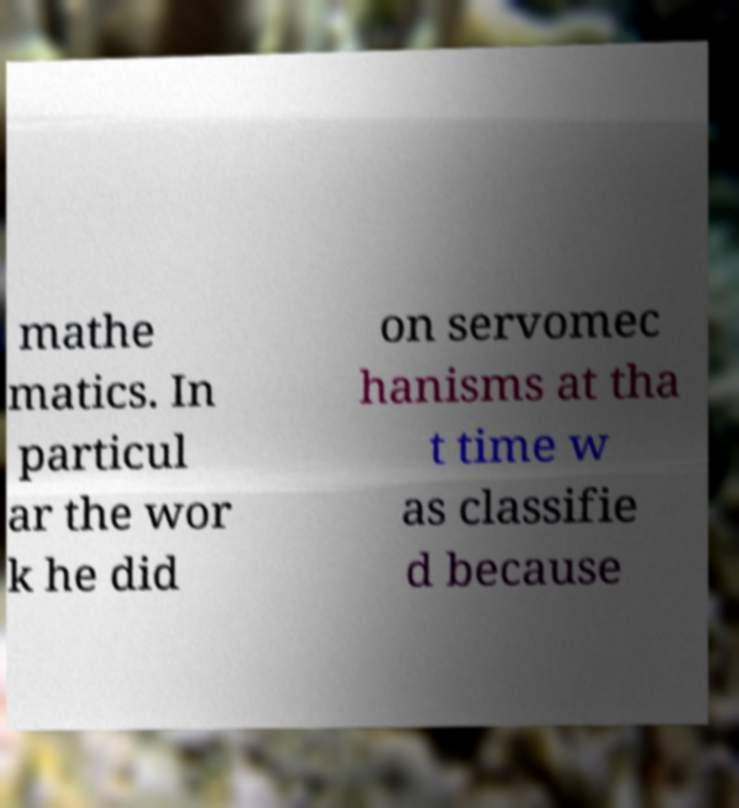What messages or text are displayed in this image? I need them in a readable, typed format. mathe matics. In particul ar the wor k he did on servomec hanisms at tha t time w as classifie d because 